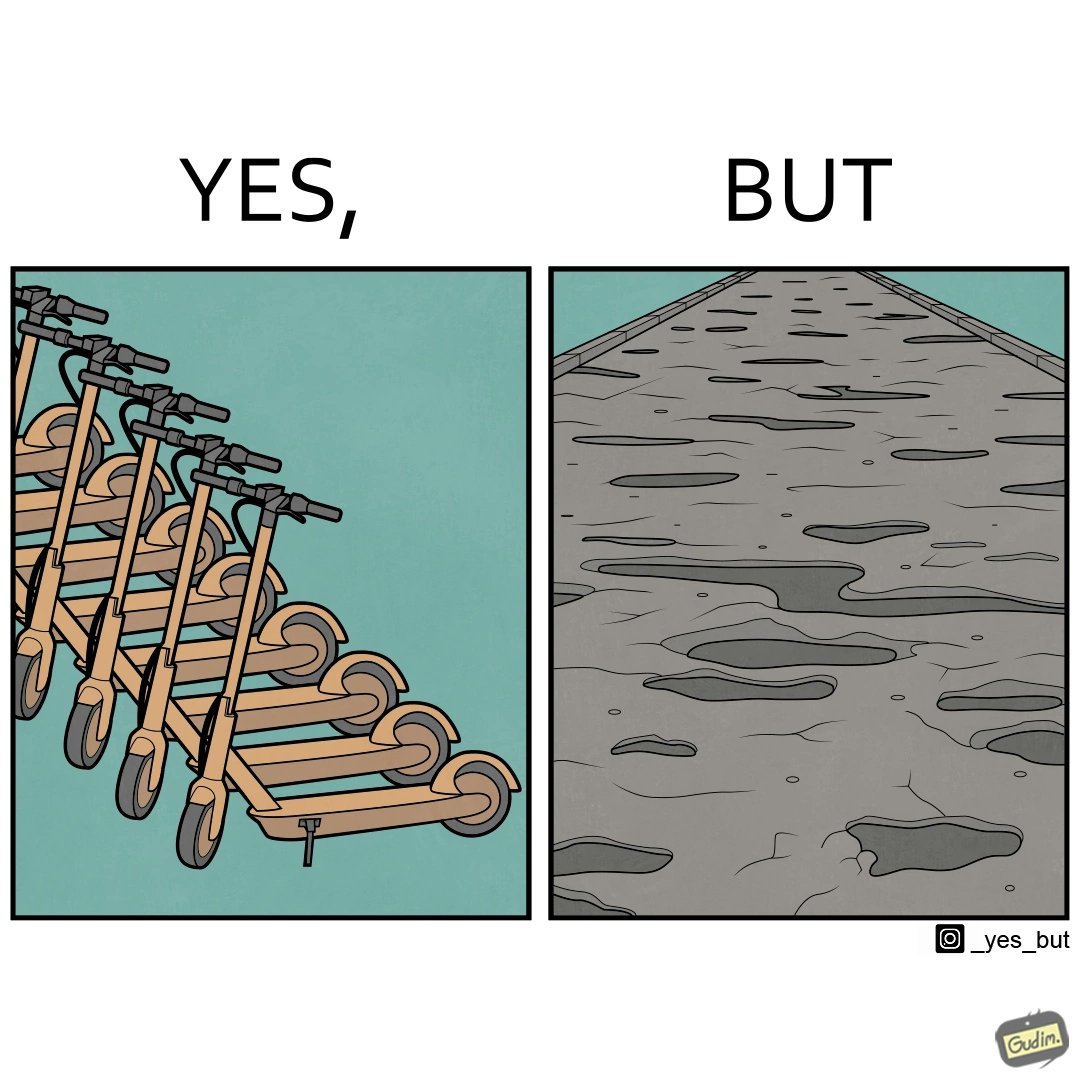Describe the satirical element in this image. The image is ironic, because even after when the skateboard scooters are available for someone to ride but the road has many potholes that it is not suitable to ride the scooters on such roads 